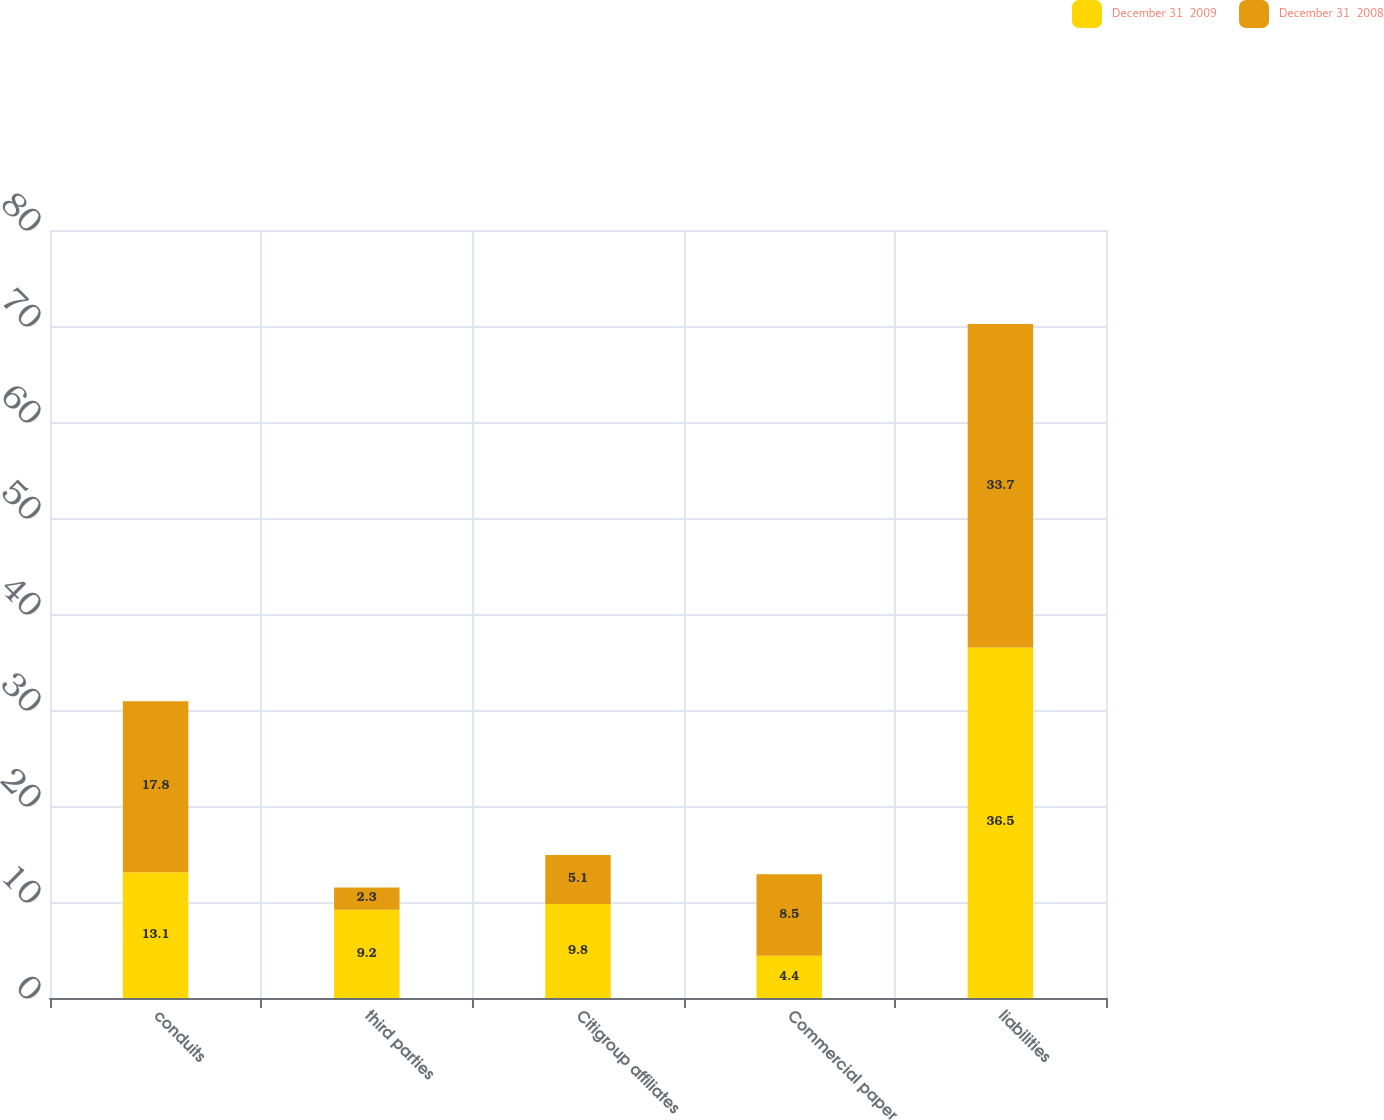<chart> <loc_0><loc_0><loc_500><loc_500><stacked_bar_chart><ecel><fcel>conduits<fcel>third parties<fcel>Citigroup affiliates<fcel>Commercial paper<fcel>liabilities<nl><fcel>December 31  2009<fcel>13.1<fcel>9.2<fcel>9.8<fcel>4.4<fcel>36.5<nl><fcel>December 31  2008<fcel>17.8<fcel>2.3<fcel>5.1<fcel>8.5<fcel>33.7<nl></chart> 